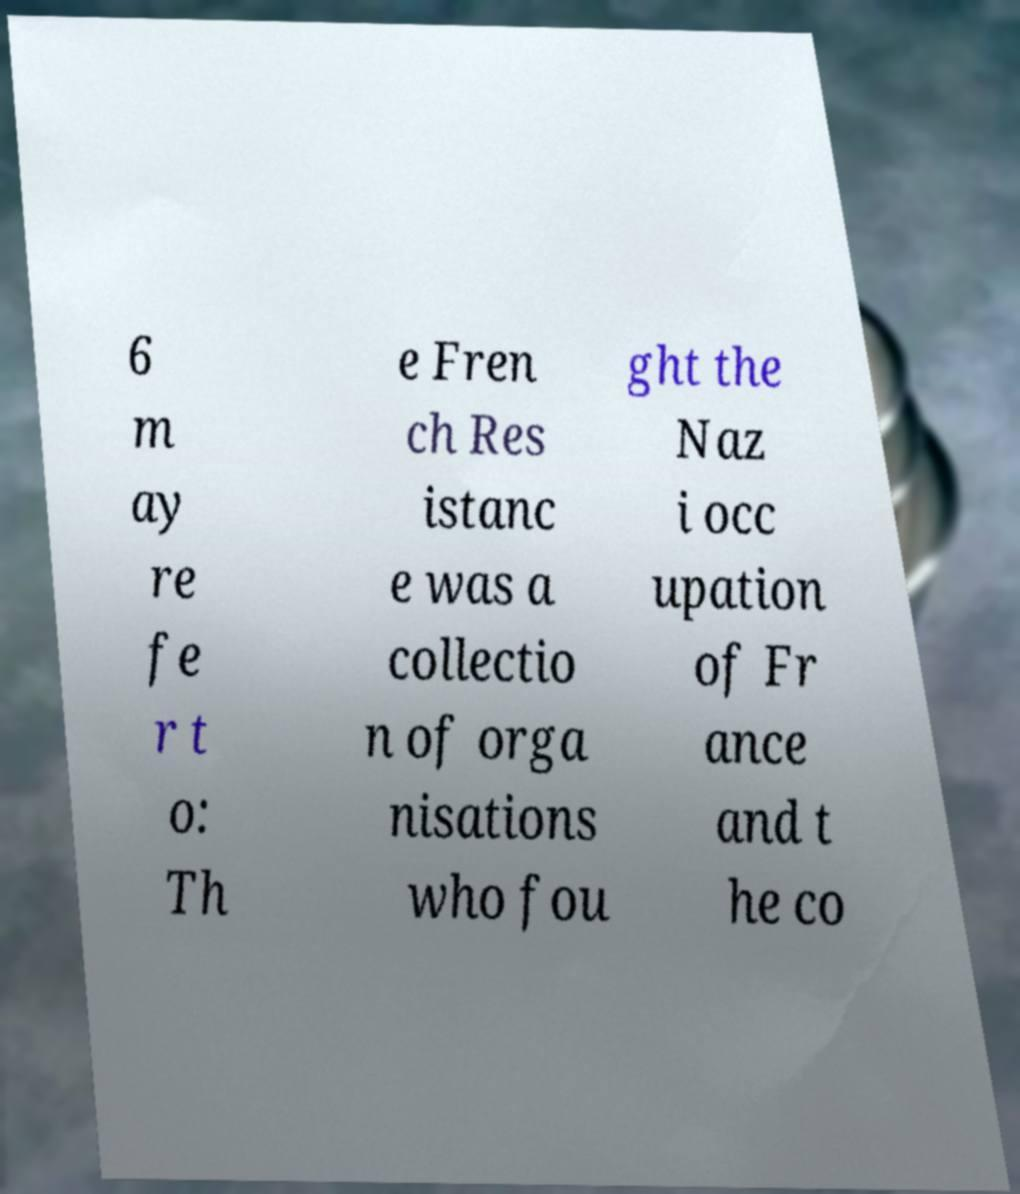For documentation purposes, I need the text within this image transcribed. Could you provide that? 6 m ay re fe r t o: Th e Fren ch Res istanc e was a collectio n of orga nisations who fou ght the Naz i occ upation of Fr ance and t he co 